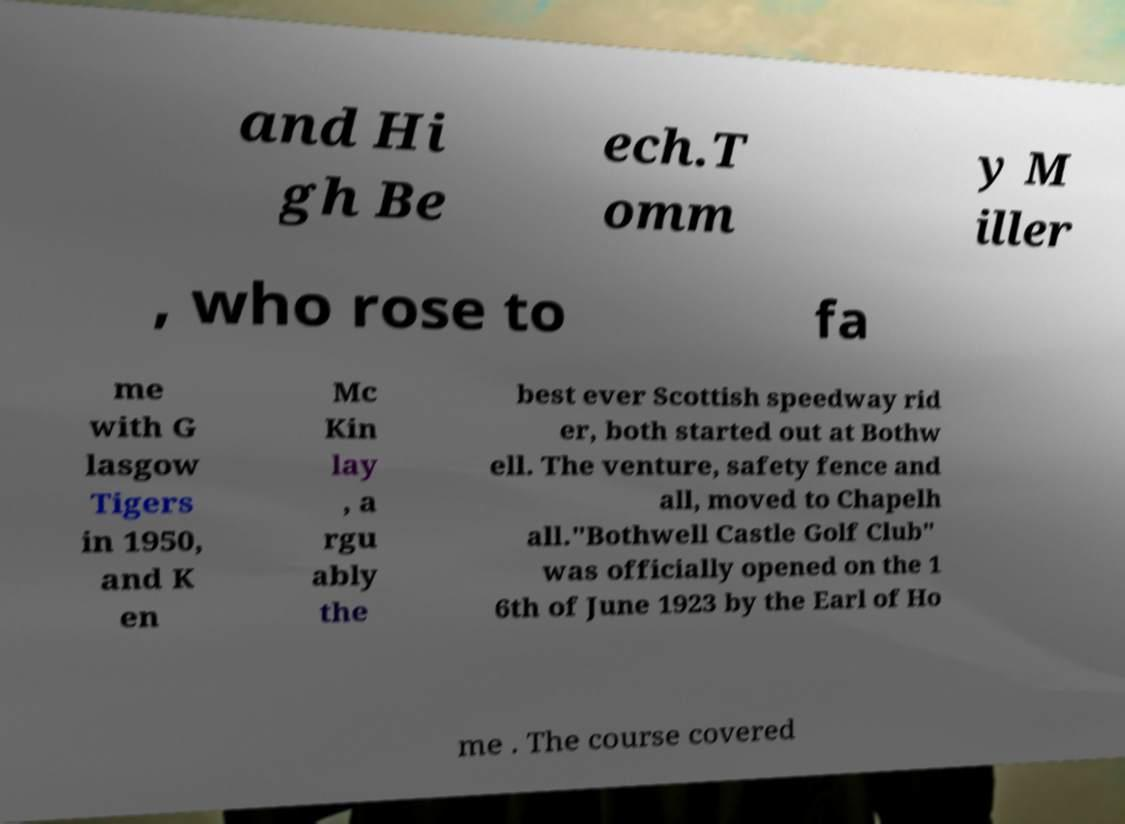There's text embedded in this image that I need extracted. Can you transcribe it verbatim? and Hi gh Be ech.T omm y M iller , who rose to fa me with G lasgow Tigers in 1950, and K en Mc Kin lay , a rgu ably the best ever Scottish speedway rid er, both started out at Bothw ell. The venture, safety fence and all, moved to Chapelh all."Bothwell Castle Golf Club" was officially opened on the 1 6th of June 1923 by the Earl of Ho me . The course covered 